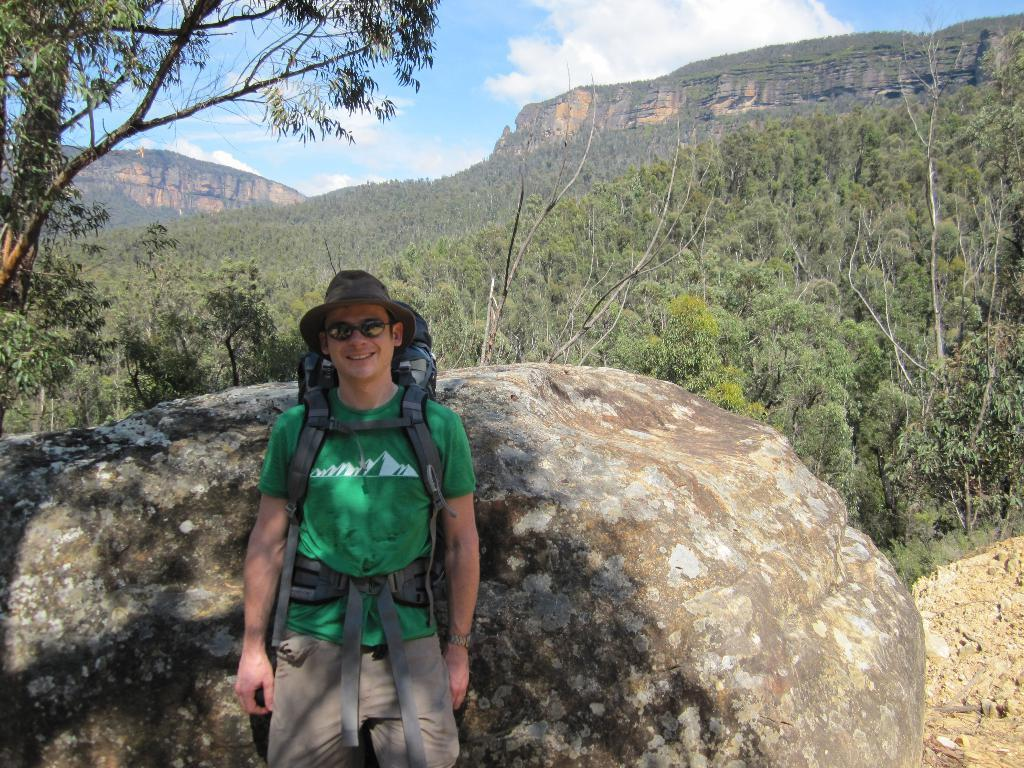What type of natural elements can be seen in the image? There are trees and a rock visible in the image. What is the man wearing in the image? The man is wearing a green t-shirt, spectacles, and a hat. What is the condition of the sky in the image? The sky is visible in the image, and clouds are present. What type of silver object is hanging from the tree in the image? There is no silver object hanging from the tree in the image; only the trees, rock, and man are present. What mathematical operation is being performed by the man in the image? There is no indication of any mathematical operation being performed in the image; the man is simply standing and wearing specific clothing and accessories. 